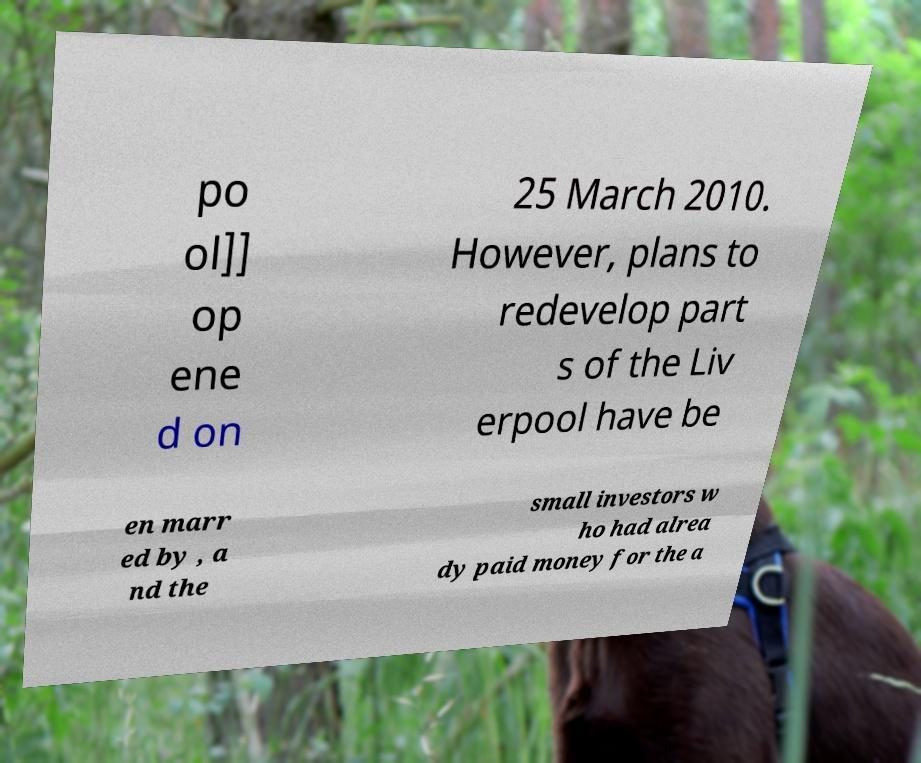What messages or text are displayed in this image? I need them in a readable, typed format. po ol]] op ene d on 25 March 2010. However, plans to redevelop part s of the Liv erpool have be en marr ed by , a nd the small investors w ho had alrea dy paid money for the a 